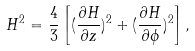Convert formula to latex. <formula><loc_0><loc_0><loc_500><loc_500>H ^ { 2 } = \frac { 4 } { 3 } \left [ ( \frac { \partial H } { \partial z } ) ^ { 2 } + ( \frac { \partial H } { \partial \phi } ) ^ { 2 } \right ] ,</formula> 